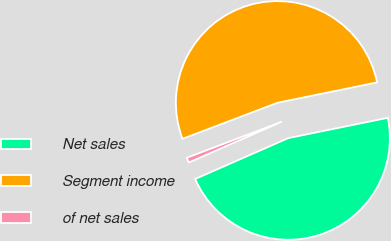Convert chart to OTSL. <chart><loc_0><loc_0><loc_500><loc_500><pie_chart><fcel>Net sales<fcel>Segment income<fcel>of net sales<nl><fcel>46.62%<fcel>52.57%<fcel>0.81%<nl></chart> 